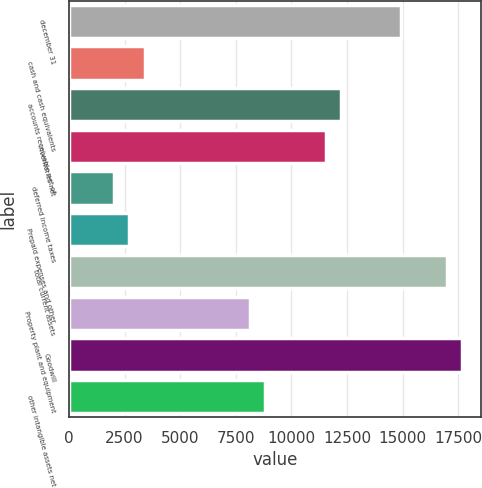<chart> <loc_0><loc_0><loc_500><loc_500><bar_chart><fcel>december 31<fcel>cash and cash equivalents<fcel>accounts receivable net of<fcel>inventories net<fcel>deferred income taxes<fcel>Prepaid expenses and other<fcel>total current assets<fcel>Property plant and equipment<fcel>Goodwill<fcel>other intangible assets net<nl><fcel>14940.4<fcel>3397.55<fcel>12224.4<fcel>11545.4<fcel>2039.57<fcel>2718.56<fcel>16977.3<fcel>8150.48<fcel>17656.3<fcel>8829.47<nl></chart> 